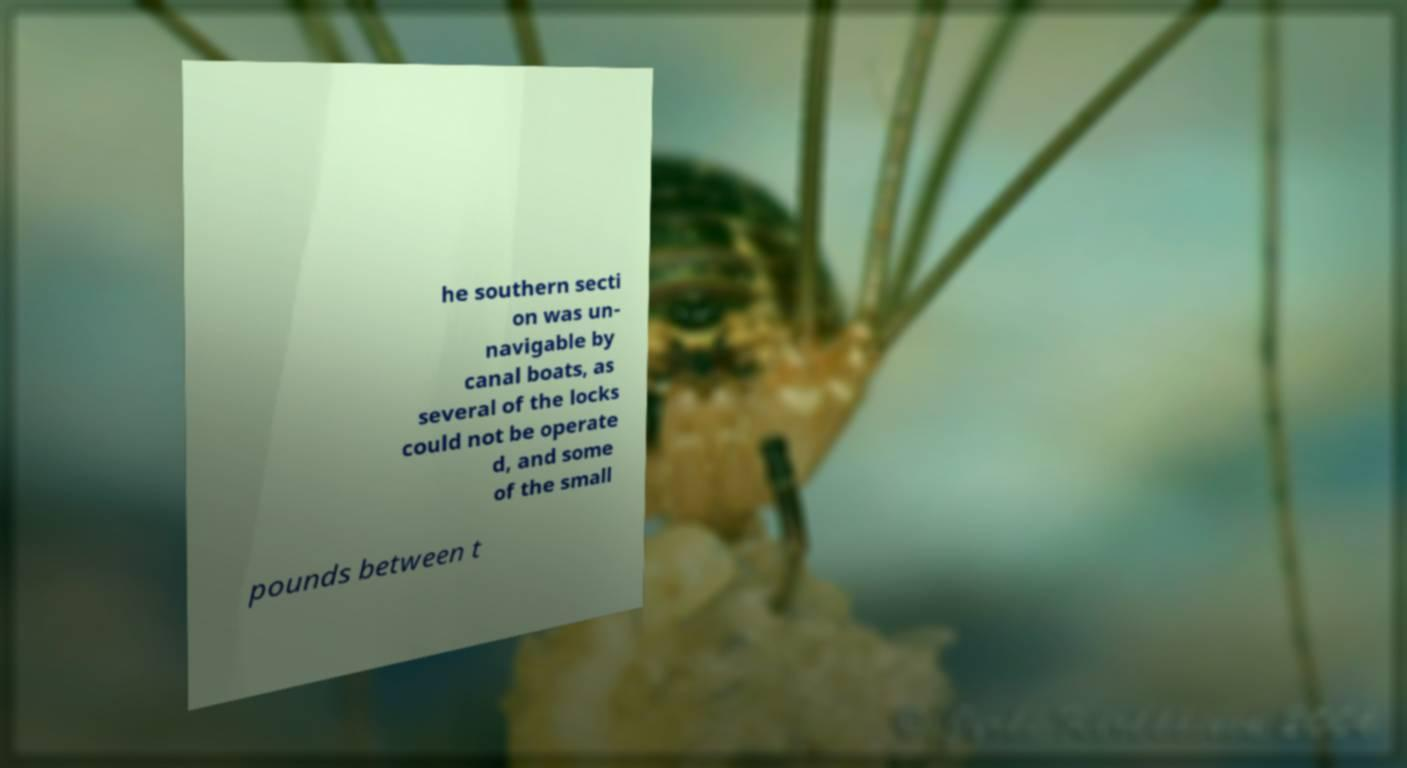For documentation purposes, I need the text within this image transcribed. Could you provide that? he southern secti on was un- navigable by canal boats, as several of the locks could not be operate d, and some of the small pounds between t 